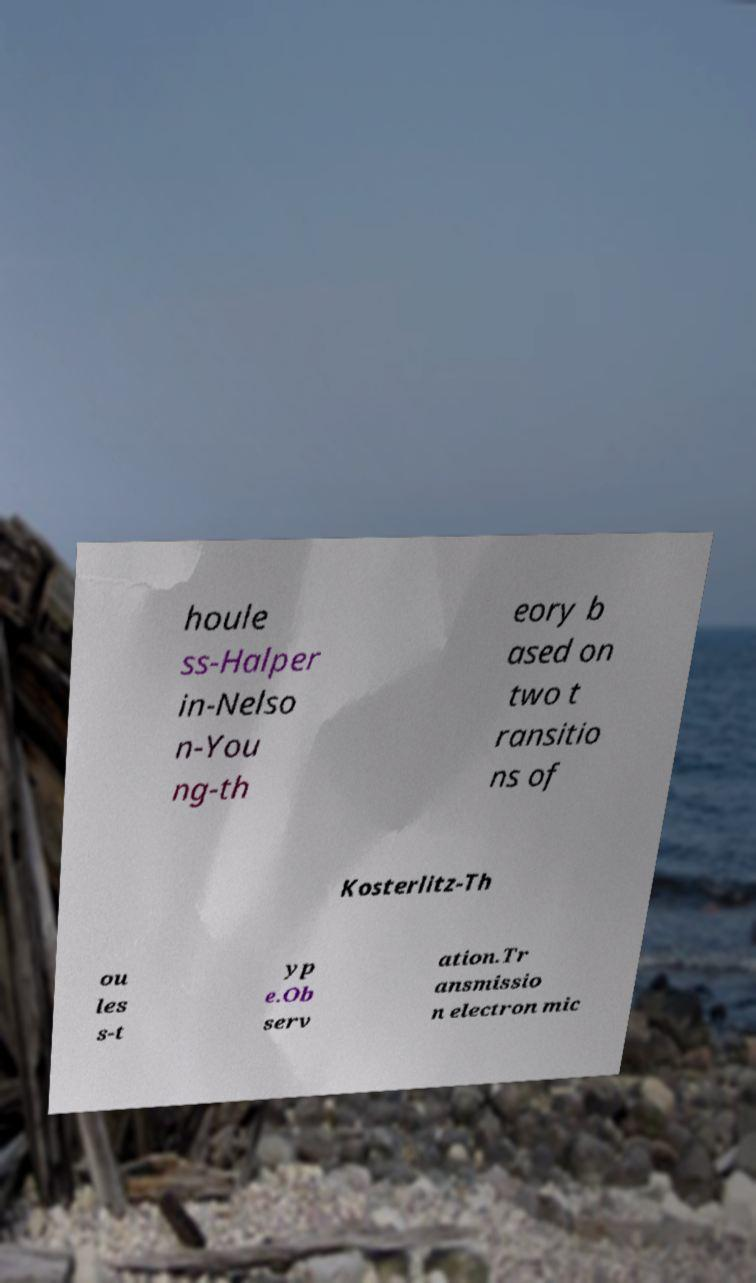Can you accurately transcribe the text from the provided image for me? houle ss-Halper in-Nelso n-You ng-th eory b ased on two t ransitio ns of Kosterlitz-Th ou les s-t yp e.Ob serv ation.Tr ansmissio n electron mic 